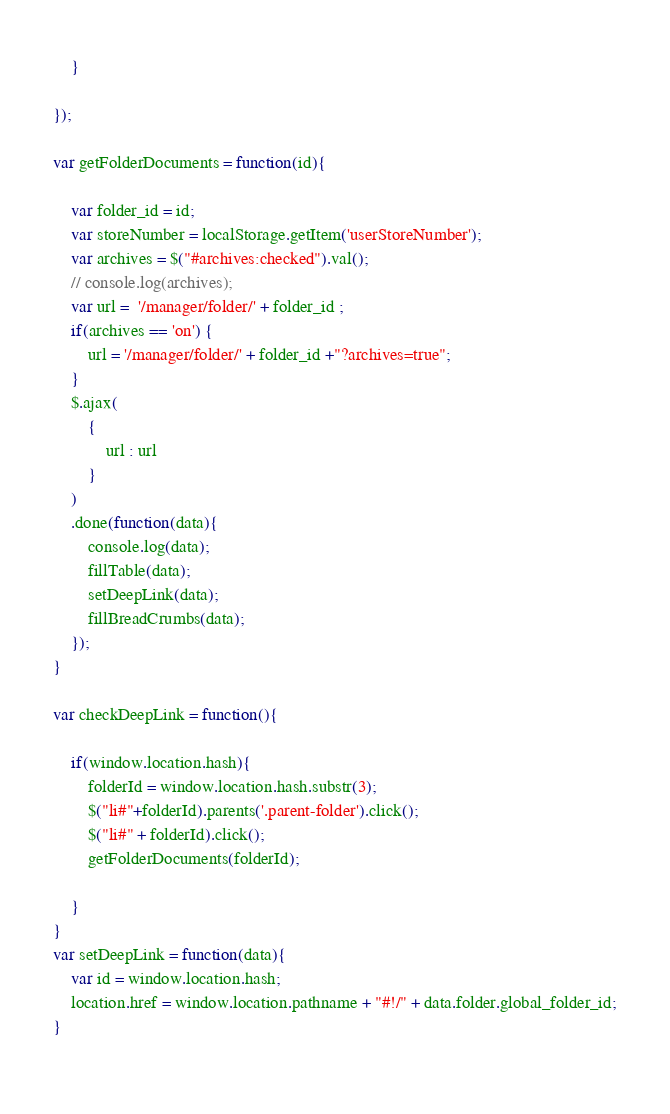<code> <loc_0><loc_0><loc_500><loc_500><_JavaScript_>	}
	
});

var getFolderDocuments = function(id){
	
	var folder_id = id;
	var storeNumber = localStorage.getItem('userStoreNumber');
	var archives = $("#archives:checked").val();
	// console.log(archives);
	var url =  '/manager/folder/' + folder_id ;
	if(archives == 'on') {
		url = '/manager/folder/' + folder_id +"?archives=true";
	}
	$.ajax(
		{
			url : url
		}
	)
	.done(function(data){
		console.log(data);
		fillTable(data);
		setDeepLink(data);
		fillBreadCrumbs(data);
	});
}

var checkDeepLink = function(){
	
	if(window.location.hash){
		folderId = window.location.hash.substr(3);
		$("li#"+folderId).parents('.parent-folder').click();
		$("li#" + folderId).click();
		getFolderDocuments(folderId);

	}
}
var setDeepLink = function(data){
	var id = window.location.hash;
	location.href = window.location.pathname + "#!/" + data.folder.global_folder_id;
}
	





</code> 